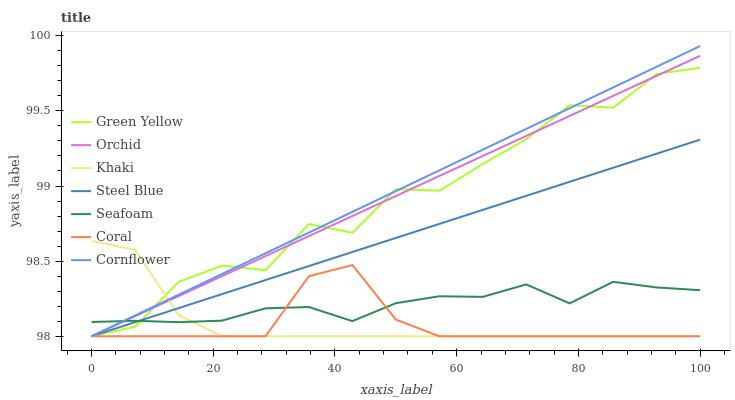Does Coral have the minimum area under the curve?
Answer yes or no. Yes. Does Cornflower have the maximum area under the curve?
Answer yes or no. Yes. Does Khaki have the minimum area under the curve?
Answer yes or no. No. Does Khaki have the maximum area under the curve?
Answer yes or no. No. Is Steel Blue the smoothest?
Answer yes or no. Yes. Is Green Yellow the roughest?
Answer yes or no. Yes. Is Khaki the smoothest?
Answer yes or no. No. Is Khaki the roughest?
Answer yes or no. No. Does Cornflower have the lowest value?
Answer yes or no. Yes. Does Seafoam have the lowest value?
Answer yes or no. No. Does Cornflower have the highest value?
Answer yes or no. Yes. Does Khaki have the highest value?
Answer yes or no. No. Does Seafoam intersect Steel Blue?
Answer yes or no. Yes. Is Seafoam less than Steel Blue?
Answer yes or no. No. Is Seafoam greater than Steel Blue?
Answer yes or no. No. 